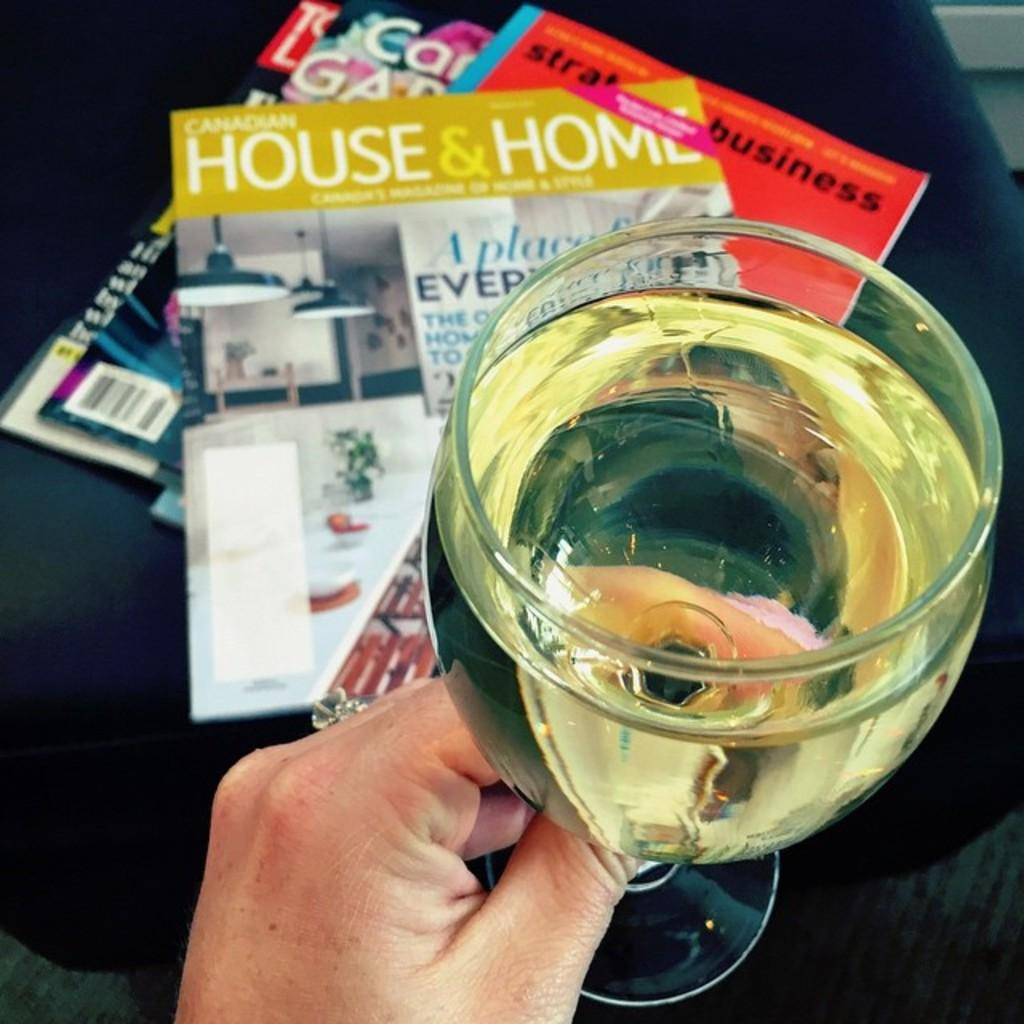<image>
Present a compact description of the photo's key features. Somebody enjoys a drink next to an issue of a House and Home magazine. 